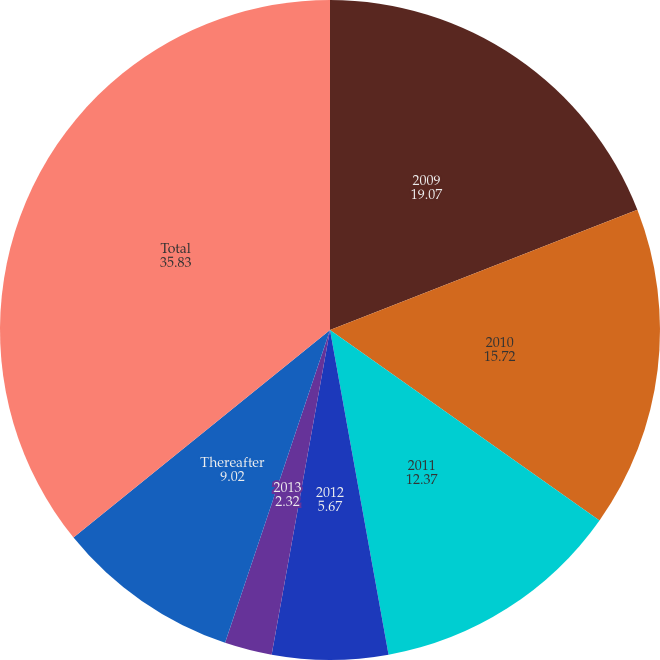<chart> <loc_0><loc_0><loc_500><loc_500><pie_chart><fcel>2009<fcel>2010<fcel>2011<fcel>2012<fcel>2013<fcel>Thereafter<fcel>Total<nl><fcel>19.07%<fcel>15.72%<fcel>12.37%<fcel>5.67%<fcel>2.32%<fcel>9.02%<fcel>35.83%<nl></chart> 